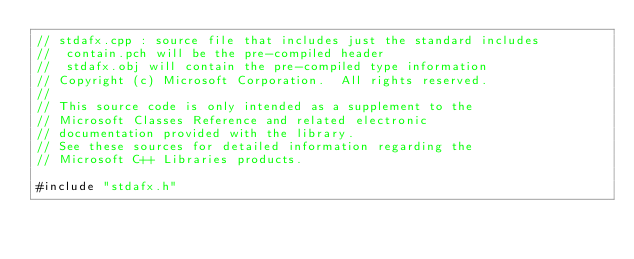<code> <loc_0><loc_0><loc_500><loc_500><_C++_>// stdafx.cpp : source file that includes just the standard includes
//	contain.pch will be the pre-compiled header
//	stdafx.obj will contain the pre-compiled type information
// Copyright (c) Microsoft Corporation.  All rights reserved.
//
// This source code is only intended as a supplement to the
// Microsoft Classes Reference and related electronic
// documentation provided with the library.
// See these sources for detailed information regarding the
// Microsoft C++ Libraries products.

#include "stdafx.h"

</code> 